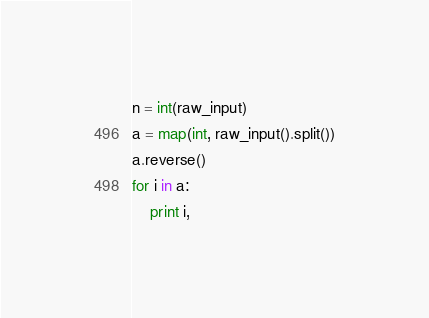<code> <loc_0><loc_0><loc_500><loc_500><_Python_>n = int(raw_input)
a = map(int, raw_input().split())
a.reverse()
for i in a:
    print i,</code> 